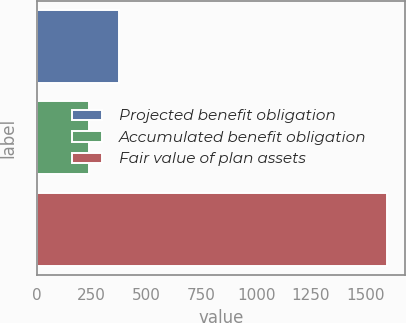<chart> <loc_0><loc_0><loc_500><loc_500><bar_chart><fcel>Projected benefit obligation<fcel>Accumulated benefit obligation<fcel>Fair value of plan assets<nl><fcel>374.95<fcel>239.1<fcel>1597.6<nl></chart> 